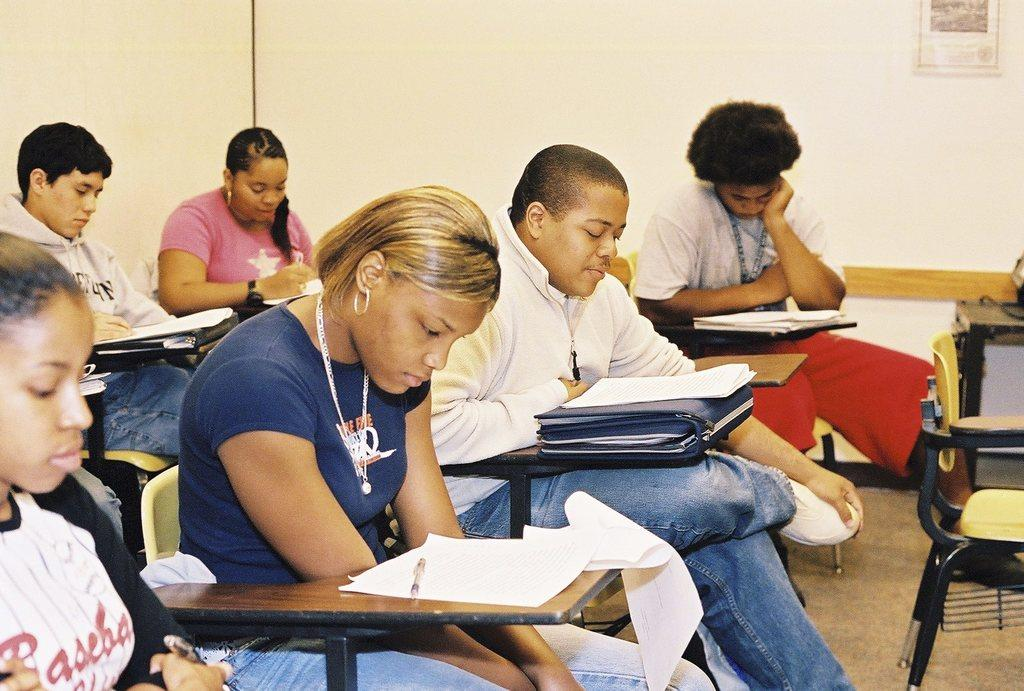How many people are in the image? There is a group of people in the image. What are the people doing in the image? The people are sitting on chairs and looking at papers. What is on the table in the image? There is a table in the image with papers, a pen, and files on it. What can be seen on the wall in the background of the image? There is a wall with a poster in the background of the image. Can you see a clam on the table in the image? No, there is no clam present on the table in the image. How many feet are visible in the image? The image does not show any feet; it only shows people sitting on chairs and looking at papers. 